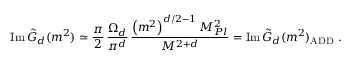<formula> <loc_0><loc_0><loc_500><loc_500>I m \, \tilde { G } _ { d } ( m ^ { 2 } ) \simeq \frac { \pi } { 2 } \, \frac { \Omega _ { d } } { \pi ^ { d } } \, \frac { \left ( m ^ { 2 } \right ) ^ { d / 2 - 1 } M _ { P l } ^ { 2 } } { M ^ { 2 + d } } = I m \, \tilde { G } _ { d } ( m ^ { 2 } ) _ { A D D } \ .</formula> 